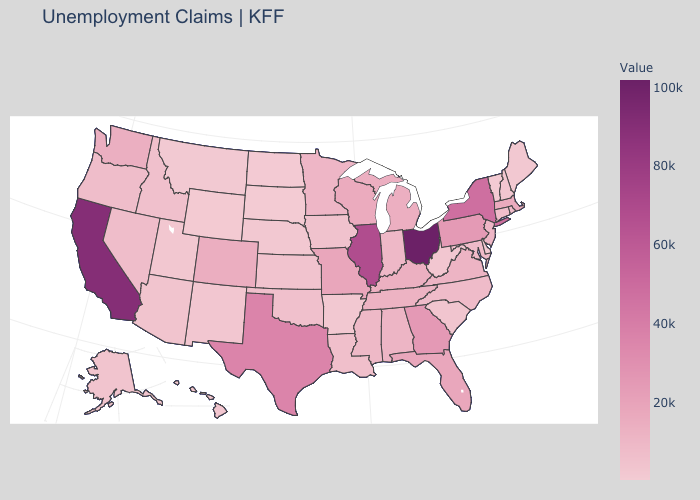Among the states that border Florida , does Alabama have the lowest value?
Answer briefly. Yes. Does the map have missing data?
Be succinct. No. Among the states that border Rhode Island , does Connecticut have the highest value?
Concise answer only. No. Among the states that border California , which have the highest value?
Write a very short answer. Nevada. Does Mississippi have the highest value in the USA?
Answer briefly. No. Does the map have missing data?
Answer briefly. No. Which states have the highest value in the USA?
Concise answer only. Ohio. Which states hav the highest value in the West?
Give a very brief answer. California. 